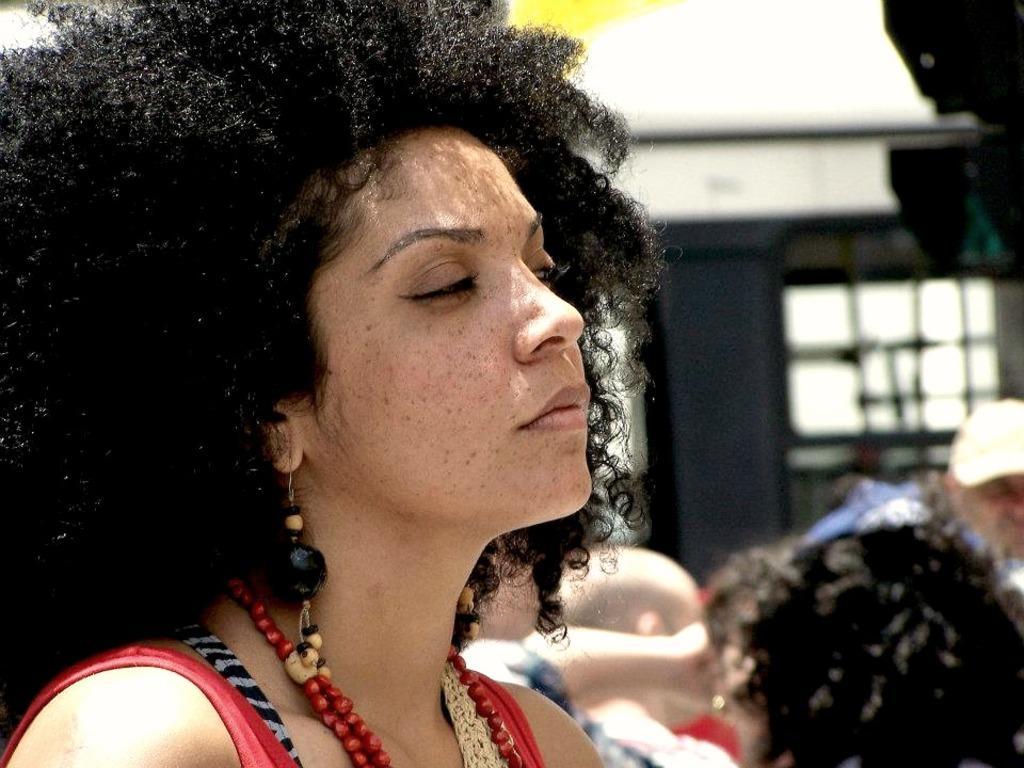Can you describe this image briefly? On the left side of the image we can see a lady is wearing a dress, chain, earrings. In the background of the image we can see the wall, windows, roof and some people are standing and a man is wearing a cap. 